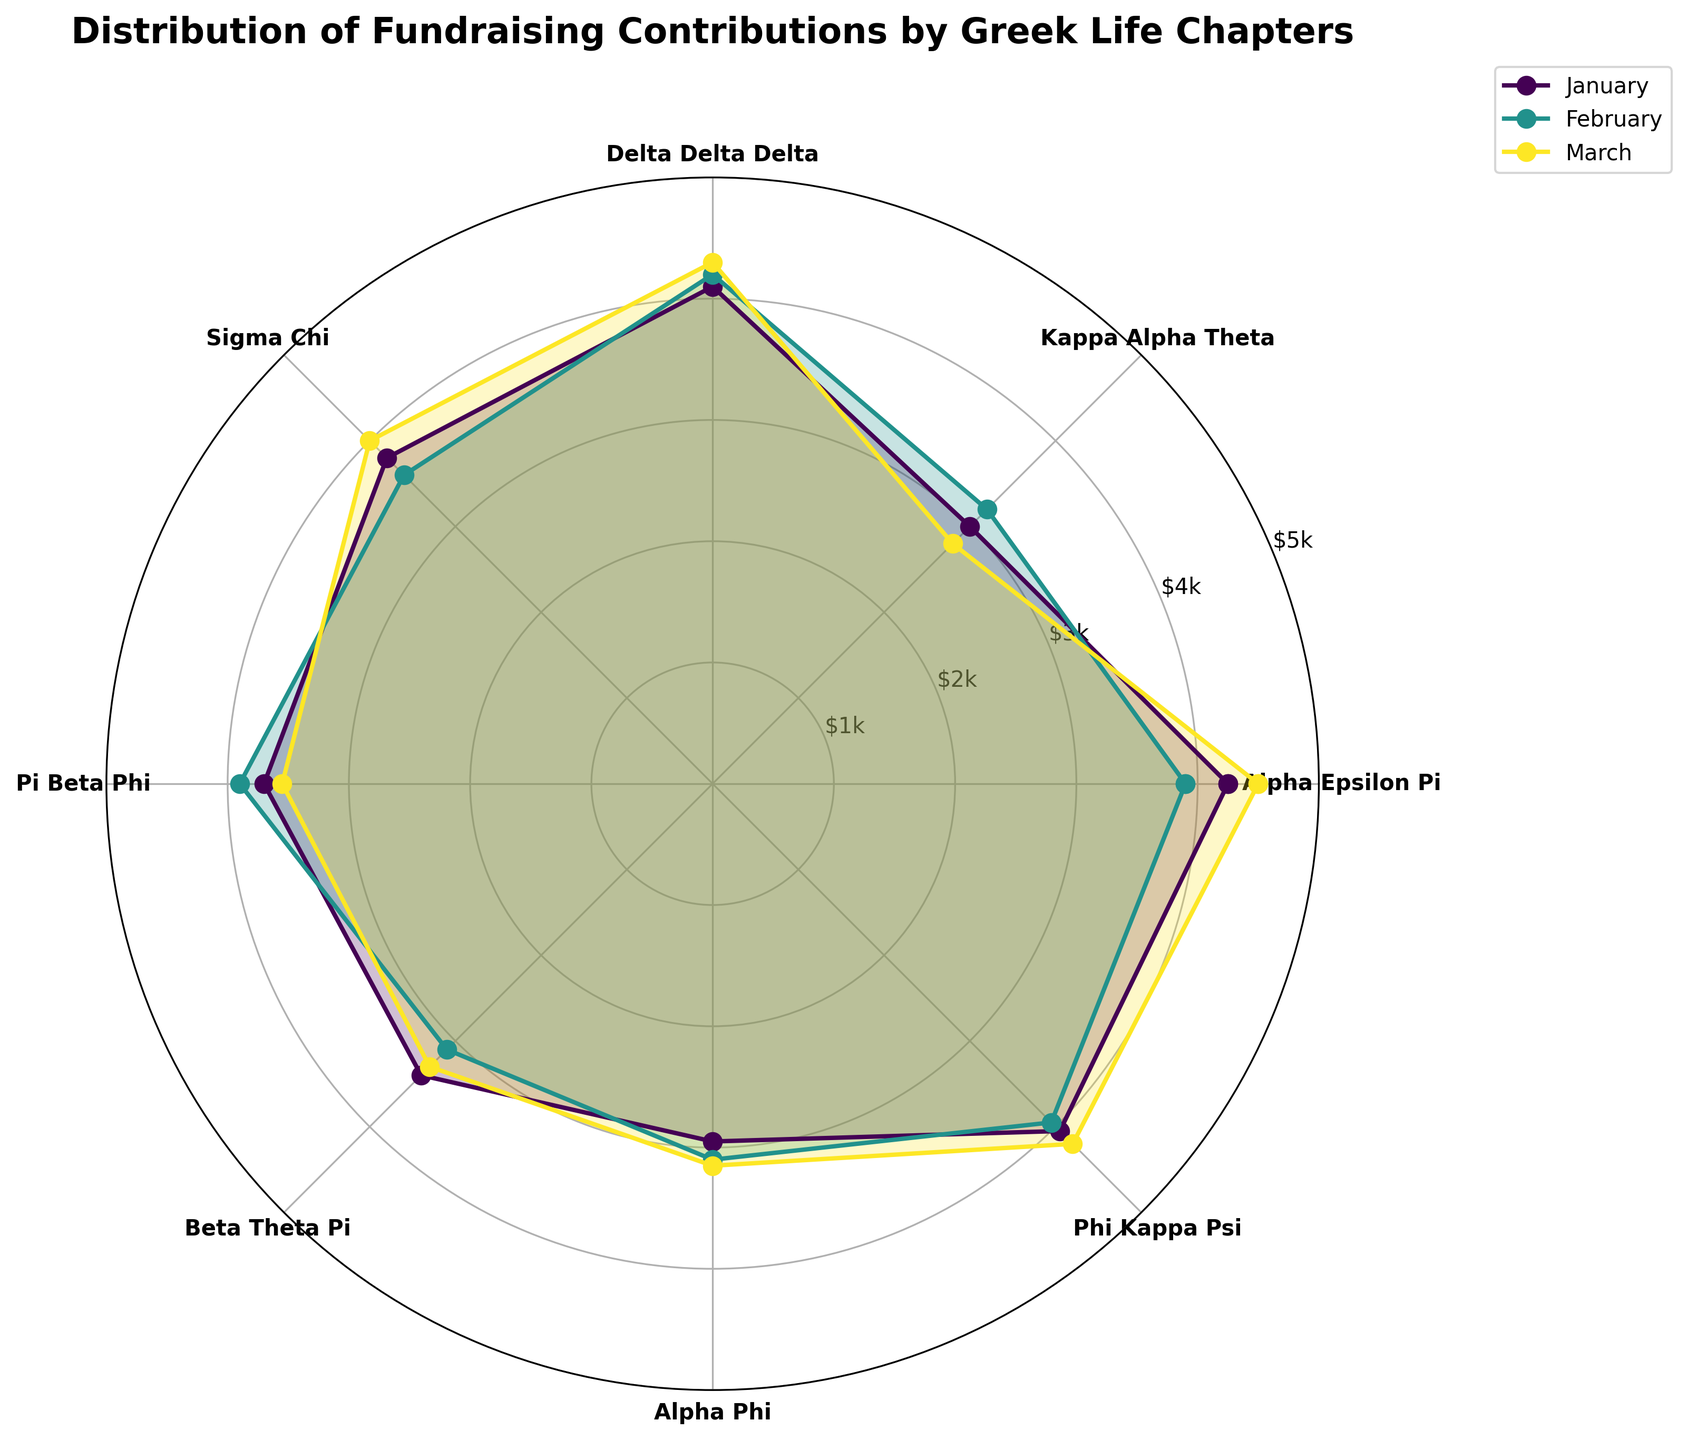Which chapter had the highest fundraising contribution in January? To identify the chapter with the highest contribution in January, look at the length of each segment in the January layer of the rose chart and compare their values. The longest segment represents the highest contribution.
Answer: Alpha Epsilon Pi How do the contributions of Alpha Epsilon Pi change from January to March? Start by locating the segments corresponding to Alpha Epsilon Pi for January, February, and March and note their lengths. Observe if the lengths increase or decrease over these months.
Answer: Increase Which month had the lowest average fundraising contributions across all chapters? Calculate the average contribution for each month by summing the contributions for all chapters in January, February, and March, then dividing by the number of chapters (7). Compare these averages to determine the lowest one.
Answer: February For Delta Delta Delta, what is the difference in contribution between January and March? Find the segments for Delta Delta Delta in January and March, note their values, and compute the difference between January's and March's contributions.
Answer: 200 Which month shows the highest contribution for Sigma Chi? Compare the lengths of the segments for Sigma Chi across January, February, and March. The month with the longest segment represents the highest contribution.
Answer: March What is the total fundraising contribution for Pi Beta Phi in the first quarter? Add the contributions for Pi Beta Phi from January, February, and March together to find the total contribution for the first quarter.
Answer: 11150 What chapter has the smallest contribution fluctuation over the three months? Identify each chapter's highest and lowest contributions over the three months and compute the difference for each. Compare these differences, and the smallest one indicates the chapter with the least fluctuation.
Answer: Alpha Phi How does the contribution pattern of Beta Theta Pi compare to Alpha Phi over the three months? Observe the segments for Beta Theta Pi and Alpha Phi across January, February, and March. Compare the trends for both chapters to find similarities or differences in their patterns.
Answer: Both chapters show a steady contribution pattern with slight variations Which chapter had a consistently high contribution in all three months? Identify chapters with consistently longer segments in the rose chart across all three months, indicating high contributions.
Answer: Alpha Epsilon Pi Which chapters had contributions exceeding $4,000 in any month? Look for segments that extend beyond the $4,000 mark in any of the three months for each chapter. Identify these chapters.
Answer: Alpha Epsilon Pi, Delta Delta Delta, Phi Kappa Psi 